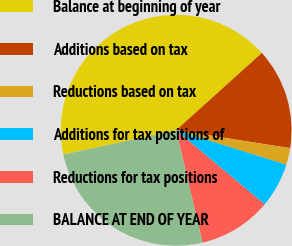Convert chart to OTSL. <chart><loc_0><loc_0><loc_500><loc_500><pie_chart><fcel>Balance at beginning of year<fcel>Additions based on tax<fcel>Reductions based on tax<fcel>Additions for tax positions of<fcel>Reductions for tax positions<fcel>BALANCE AT END OF YEAR<nl><fcel>41.7%<fcel>14.15%<fcel>2.35%<fcel>6.28%<fcel>10.22%<fcel>25.3%<nl></chart> 